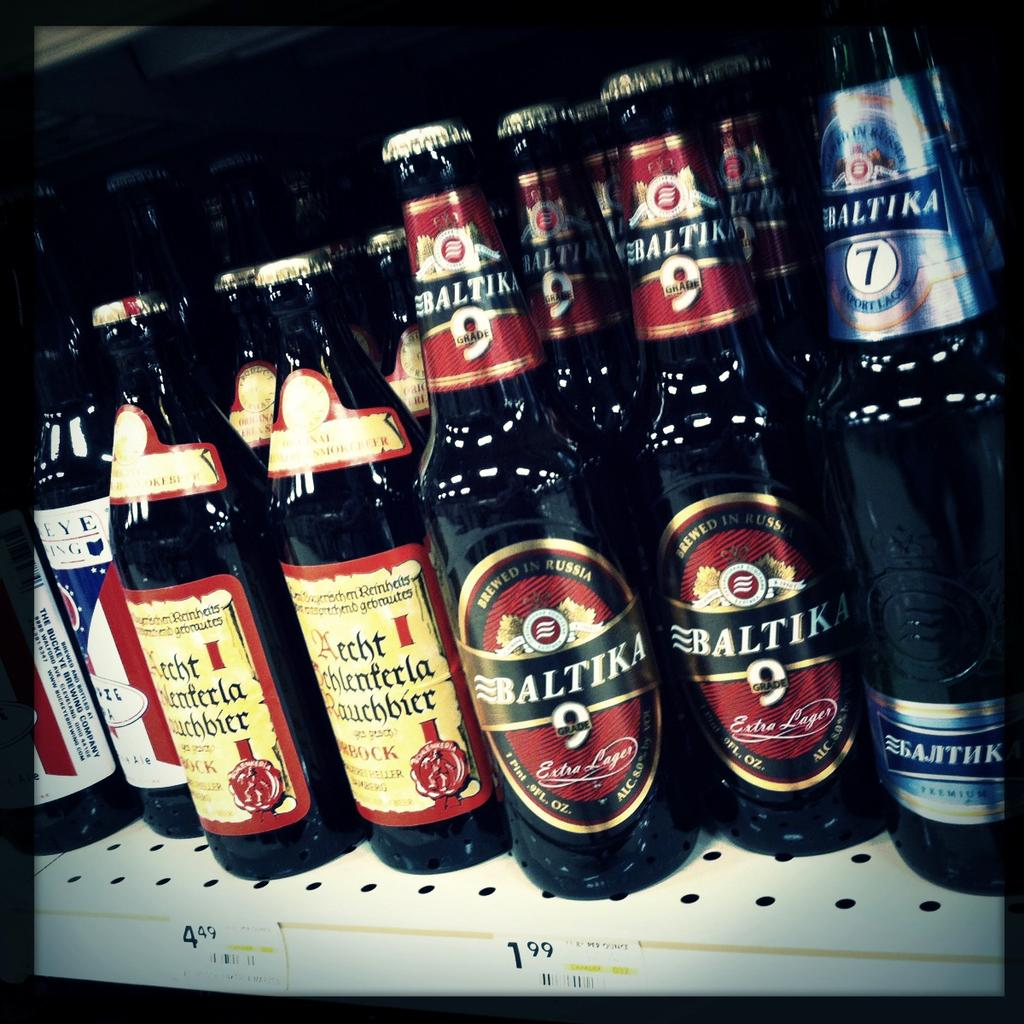Provide a one-sentence caption for the provided image. Baltika bottles of beer are on a shelf next to other bottles. 